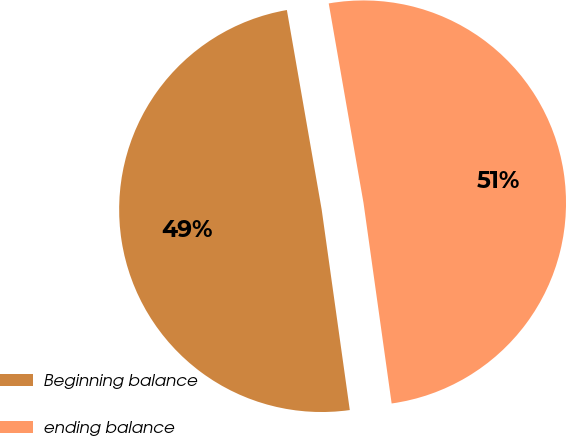Convert chart. <chart><loc_0><loc_0><loc_500><loc_500><pie_chart><fcel>Beginning balance<fcel>ending balance<nl><fcel>49.47%<fcel>50.53%<nl></chart> 